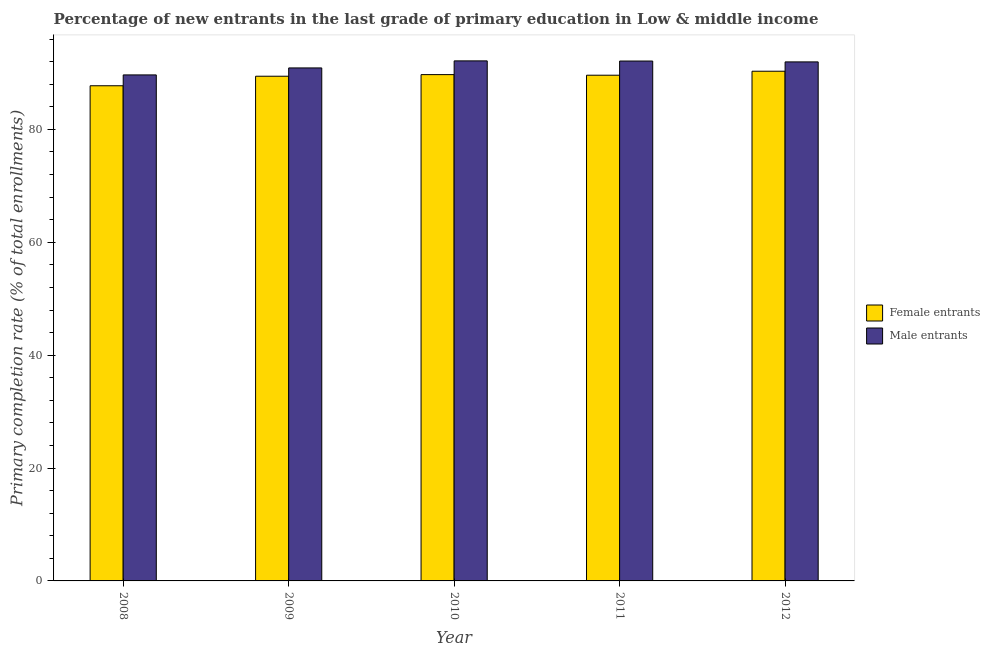How many bars are there on the 1st tick from the left?
Give a very brief answer. 2. How many bars are there on the 4th tick from the right?
Keep it short and to the point. 2. In how many cases, is the number of bars for a given year not equal to the number of legend labels?
Provide a short and direct response. 0. What is the primary completion rate of female entrants in 2008?
Your answer should be very brief. 87.74. Across all years, what is the maximum primary completion rate of male entrants?
Offer a terse response. 92.14. Across all years, what is the minimum primary completion rate of female entrants?
Ensure brevity in your answer.  87.74. In which year was the primary completion rate of female entrants minimum?
Give a very brief answer. 2008. What is the total primary completion rate of male entrants in the graph?
Your response must be concise. 456.77. What is the difference between the primary completion rate of female entrants in 2009 and that in 2010?
Make the answer very short. -0.29. What is the difference between the primary completion rate of male entrants in 2009 and the primary completion rate of female entrants in 2008?
Offer a very short reply. 1.24. What is the average primary completion rate of female entrants per year?
Your answer should be compact. 89.36. In the year 2008, what is the difference between the primary completion rate of female entrants and primary completion rate of male entrants?
Give a very brief answer. 0. What is the ratio of the primary completion rate of female entrants in 2008 to that in 2012?
Your answer should be compact. 0.97. Is the primary completion rate of female entrants in 2009 less than that in 2011?
Your answer should be very brief. Yes. What is the difference between the highest and the second highest primary completion rate of male entrants?
Ensure brevity in your answer.  0.03. What is the difference between the highest and the lowest primary completion rate of male entrants?
Your answer should be very brief. 2.49. What does the 1st bar from the left in 2011 represents?
Your response must be concise. Female entrants. What does the 2nd bar from the right in 2010 represents?
Give a very brief answer. Female entrants. How many bars are there?
Offer a terse response. 10. Are all the bars in the graph horizontal?
Make the answer very short. No. How many years are there in the graph?
Your response must be concise. 5. What is the difference between two consecutive major ticks on the Y-axis?
Provide a succinct answer. 20. Does the graph contain any zero values?
Offer a terse response. No. Where does the legend appear in the graph?
Your answer should be compact. Center right. How many legend labels are there?
Ensure brevity in your answer.  2. How are the legend labels stacked?
Offer a terse response. Vertical. What is the title of the graph?
Provide a succinct answer. Percentage of new entrants in the last grade of primary education in Low & middle income. Does "Primary income" appear as one of the legend labels in the graph?
Make the answer very short. No. What is the label or title of the Y-axis?
Your answer should be compact. Primary completion rate (% of total enrollments). What is the Primary completion rate (% of total enrollments) of Female entrants in 2008?
Your answer should be very brief. 87.74. What is the Primary completion rate (% of total enrollments) of Male entrants in 2008?
Provide a short and direct response. 89.66. What is the Primary completion rate (% of total enrollments) of Female entrants in 2009?
Provide a succinct answer. 89.42. What is the Primary completion rate (% of total enrollments) of Male entrants in 2009?
Your answer should be very brief. 90.89. What is the Primary completion rate (% of total enrollments) in Female entrants in 2010?
Ensure brevity in your answer.  89.71. What is the Primary completion rate (% of total enrollments) in Male entrants in 2010?
Keep it short and to the point. 92.14. What is the Primary completion rate (% of total enrollments) in Female entrants in 2011?
Your answer should be compact. 89.6. What is the Primary completion rate (% of total enrollments) in Male entrants in 2011?
Provide a short and direct response. 92.11. What is the Primary completion rate (% of total enrollments) of Female entrants in 2012?
Offer a very short reply. 90.31. What is the Primary completion rate (% of total enrollments) in Male entrants in 2012?
Make the answer very short. 91.96. Across all years, what is the maximum Primary completion rate (% of total enrollments) in Female entrants?
Keep it short and to the point. 90.31. Across all years, what is the maximum Primary completion rate (% of total enrollments) in Male entrants?
Ensure brevity in your answer.  92.14. Across all years, what is the minimum Primary completion rate (% of total enrollments) in Female entrants?
Offer a very short reply. 87.74. Across all years, what is the minimum Primary completion rate (% of total enrollments) of Male entrants?
Your response must be concise. 89.66. What is the total Primary completion rate (% of total enrollments) of Female entrants in the graph?
Provide a succinct answer. 446.78. What is the total Primary completion rate (% of total enrollments) of Male entrants in the graph?
Keep it short and to the point. 456.77. What is the difference between the Primary completion rate (% of total enrollments) of Female entrants in 2008 and that in 2009?
Keep it short and to the point. -1.69. What is the difference between the Primary completion rate (% of total enrollments) in Male entrants in 2008 and that in 2009?
Your response must be concise. -1.24. What is the difference between the Primary completion rate (% of total enrollments) in Female entrants in 2008 and that in 2010?
Offer a very short reply. -1.97. What is the difference between the Primary completion rate (% of total enrollments) of Male entrants in 2008 and that in 2010?
Give a very brief answer. -2.49. What is the difference between the Primary completion rate (% of total enrollments) in Female entrants in 2008 and that in 2011?
Keep it short and to the point. -1.87. What is the difference between the Primary completion rate (% of total enrollments) in Male entrants in 2008 and that in 2011?
Ensure brevity in your answer.  -2.46. What is the difference between the Primary completion rate (% of total enrollments) of Female entrants in 2008 and that in 2012?
Your answer should be very brief. -2.57. What is the difference between the Primary completion rate (% of total enrollments) of Male entrants in 2008 and that in 2012?
Offer a very short reply. -2.31. What is the difference between the Primary completion rate (% of total enrollments) of Female entrants in 2009 and that in 2010?
Provide a succinct answer. -0.29. What is the difference between the Primary completion rate (% of total enrollments) in Male entrants in 2009 and that in 2010?
Your answer should be compact. -1.25. What is the difference between the Primary completion rate (% of total enrollments) in Female entrants in 2009 and that in 2011?
Offer a very short reply. -0.18. What is the difference between the Primary completion rate (% of total enrollments) in Male entrants in 2009 and that in 2011?
Your answer should be compact. -1.22. What is the difference between the Primary completion rate (% of total enrollments) of Female entrants in 2009 and that in 2012?
Your answer should be compact. -0.89. What is the difference between the Primary completion rate (% of total enrollments) of Male entrants in 2009 and that in 2012?
Your answer should be very brief. -1.07. What is the difference between the Primary completion rate (% of total enrollments) of Female entrants in 2010 and that in 2011?
Ensure brevity in your answer.  0.11. What is the difference between the Primary completion rate (% of total enrollments) in Female entrants in 2010 and that in 2012?
Provide a succinct answer. -0.6. What is the difference between the Primary completion rate (% of total enrollments) in Male entrants in 2010 and that in 2012?
Offer a terse response. 0.18. What is the difference between the Primary completion rate (% of total enrollments) in Female entrants in 2011 and that in 2012?
Keep it short and to the point. -0.71. What is the difference between the Primary completion rate (% of total enrollments) in Male entrants in 2011 and that in 2012?
Your answer should be compact. 0.15. What is the difference between the Primary completion rate (% of total enrollments) in Female entrants in 2008 and the Primary completion rate (% of total enrollments) in Male entrants in 2009?
Your answer should be compact. -3.16. What is the difference between the Primary completion rate (% of total enrollments) in Female entrants in 2008 and the Primary completion rate (% of total enrollments) in Male entrants in 2010?
Make the answer very short. -4.41. What is the difference between the Primary completion rate (% of total enrollments) in Female entrants in 2008 and the Primary completion rate (% of total enrollments) in Male entrants in 2011?
Offer a very short reply. -4.38. What is the difference between the Primary completion rate (% of total enrollments) of Female entrants in 2008 and the Primary completion rate (% of total enrollments) of Male entrants in 2012?
Offer a very short reply. -4.23. What is the difference between the Primary completion rate (% of total enrollments) in Female entrants in 2009 and the Primary completion rate (% of total enrollments) in Male entrants in 2010?
Provide a succinct answer. -2.72. What is the difference between the Primary completion rate (% of total enrollments) of Female entrants in 2009 and the Primary completion rate (% of total enrollments) of Male entrants in 2011?
Make the answer very short. -2.69. What is the difference between the Primary completion rate (% of total enrollments) of Female entrants in 2009 and the Primary completion rate (% of total enrollments) of Male entrants in 2012?
Provide a succinct answer. -2.54. What is the difference between the Primary completion rate (% of total enrollments) of Female entrants in 2010 and the Primary completion rate (% of total enrollments) of Male entrants in 2011?
Offer a very short reply. -2.4. What is the difference between the Primary completion rate (% of total enrollments) in Female entrants in 2010 and the Primary completion rate (% of total enrollments) in Male entrants in 2012?
Your response must be concise. -2.25. What is the difference between the Primary completion rate (% of total enrollments) in Female entrants in 2011 and the Primary completion rate (% of total enrollments) in Male entrants in 2012?
Your answer should be compact. -2.36. What is the average Primary completion rate (% of total enrollments) in Female entrants per year?
Your answer should be very brief. 89.36. What is the average Primary completion rate (% of total enrollments) of Male entrants per year?
Make the answer very short. 91.35. In the year 2008, what is the difference between the Primary completion rate (% of total enrollments) in Female entrants and Primary completion rate (% of total enrollments) in Male entrants?
Provide a short and direct response. -1.92. In the year 2009, what is the difference between the Primary completion rate (% of total enrollments) of Female entrants and Primary completion rate (% of total enrollments) of Male entrants?
Ensure brevity in your answer.  -1.47. In the year 2010, what is the difference between the Primary completion rate (% of total enrollments) of Female entrants and Primary completion rate (% of total enrollments) of Male entrants?
Provide a short and direct response. -2.43. In the year 2011, what is the difference between the Primary completion rate (% of total enrollments) of Female entrants and Primary completion rate (% of total enrollments) of Male entrants?
Keep it short and to the point. -2.51. In the year 2012, what is the difference between the Primary completion rate (% of total enrollments) of Female entrants and Primary completion rate (% of total enrollments) of Male entrants?
Keep it short and to the point. -1.65. What is the ratio of the Primary completion rate (% of total enrollments) of Female entrants in 2008 to that in 2009?
Keep it short and to the point. 0.98. What is the ratio of the Primary completion rate (% of total enrollments) in Male entrants in 2008 to that in 2009?
Give a very brief answer. 0.99. What is the ratio of the Primary completion rate (% of total enrollments) of Female entrants in 2008 to that in 2010?
Offer a very short reply. 0.98. What is the ratio of the Primary completion rate (% of total enrollments) of Female entrants in 2008 to that in 2011?
Make the answer very short. 0.98. What is the ratio of the Primary completion rate (% of total enrollments) in Male entrants in 2008 to that in 2011?
Provide a succinct answer. 0.97. What is the ratio of the Primary completion rate (% of total enrollments) of Female entrants in 2008 to that in 2012?
Keep it short and to the point. 0.97. What is the ratio of the Primary completion rate (% of total enrollments) in Male entrants in 2008 to that in 2012?
Your response must be concise. 0.97. What is the ratio of the Primary completion rate (% of total enrollments) of Male entrants in 2009 to that in 2010?
Your answer should be very brief. 0.99. What is the ratio of the Primary completion rate (% of total enrollments) in Female entrants in 2009 to that in 2011?
Give a very brief answer. 1. What is the ratio of the Primary completion rate (% of total enrollments) in Male entrants in 2009 to that in 2011?
Ensure brevity in your answer.  0.99. What is the ratio of the Primary completion rate (% of total enrollments) of Female entrants in 2009 to that in 2012?
Make the answer very short. 0.99. What is the ratio of the Primary completion rate (% of total enrollments) of Male entrants in 2009 to that in 2012?
Keep it short and to the point. 0.99. What is the ratio of the Primary completion rate (% of total enrollments) in Female entrants in 2010 to that in 2011?
Provide a succinct answer. 1. What is the ratio of the Primary completion rate (% of total enrollments) of Male entrants in 2010 to that in 2011?
Your response must be concise. 1. What is the ratio of the Primary completion rate (% of total enrollments) in Male entrants in 2010 to that in 2012?
Your response must be concise. 1. What is the ratio of the Primary completion rate (% of total enrollments) of Female entrants in 2011 to that in 2012?
Give a very brief answer. 0.99. What is the ratio of the Primary completion rate (% of total enrollments) in Male entrants in 2011 to that in 2012?
Ensure brevity in your answer.  1. What is the difference between the highest and the second highest Primary completion rate (% of total enrollments) of Female entrants?
Your response must be concise. 0.6. What is the difference between the highest and the second highest Primary completion rate (% of total enrollments) in Male entrants?
Keep it short and to the point. 0.03. What is the difference between the highest and the lowest Primary completion rate (% of total enrollments) of Female entrants?
Provide a short and direct response. 2.57. What is the difference between the highest and the lowest Primary completion rate (% of total enrollments) of Male entrants?
Make the answer very short. 2.49. 